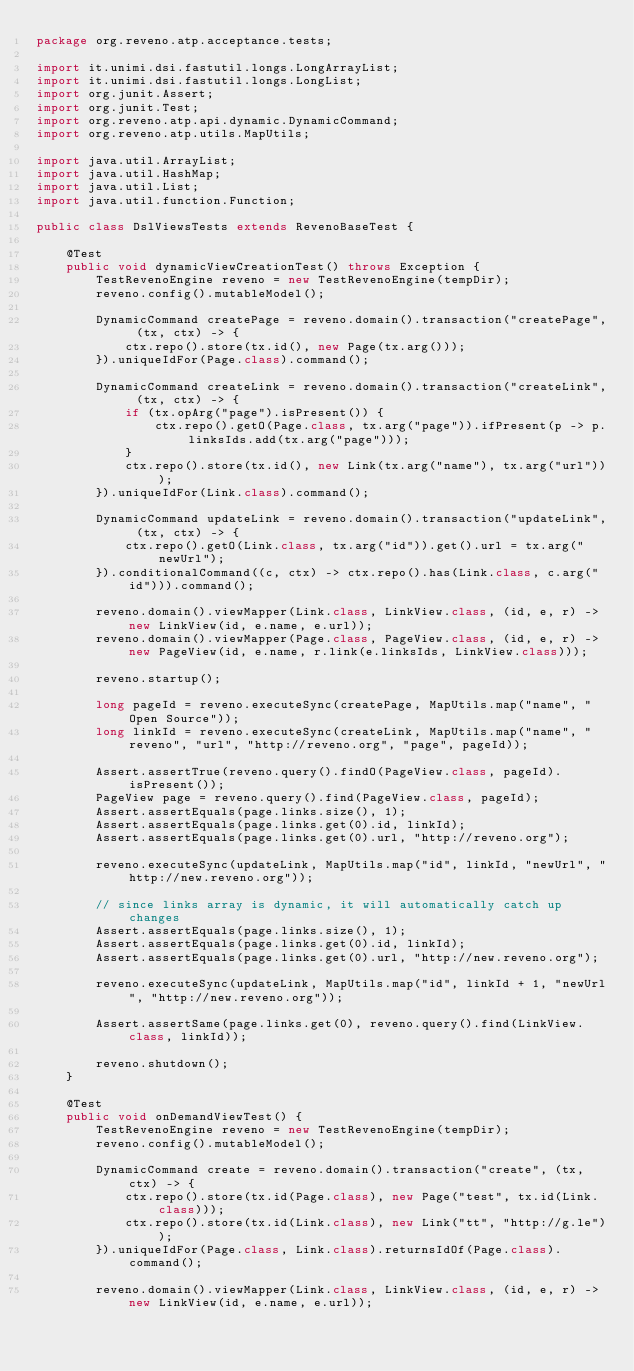Convert code to text. <code><loc_0><loc_0><loc_500><loc_500><_Java_>package org.reveno.atp.acceptance.tests;

import it.unimi.dsi.fastutil.longs.LongArrayList;
import it.unimi.dsi.fastutil.longs.LongList;
import org.junit.Assert;
import org.junit.Test;
import org.reveno.atp.api.dynamic.DynamicCommand;
import org.reveno.atp.utils.MapUtils;

import java.util.ArrayList;
import java.util.HashMap;
import java.util.List;
import java.util.function.Function;

public class DslViewsTests extends RevenoBaseTest {

    @Test
    public void dynamicViewCreationTest() throws Exception {
        TestRevenoEngine reveno = new TestRevenoEngine(tempDir);
        reveno.config().mutableModel();

        DynamicCommand createPage = reveno.domain().transaction("createPage", (tx, ctx) -> {
            ctx.repo().store(tx.id(), new Page(tx.arg()));
        }).uniqueIdFor(Page.class).command();

        DynamicCommand createLink = reveno.domain().transaction("createLink", (tx, ctx) -> {
            if (tx.opArg("page").isPresent()) {
                ctx.repo().getO(Page.class, tx.arg("page")).ifPresent(p -> p.linksIds.add(tx.arg("page")));
            }
            ctx.repo().store(tx.id(), new Link(tx.arg("name"), tx.arg("url")));
        }).uniqueIdFor(Link.class).command();

        DynamicCommand updateLink = reveno.domain().transaction("updateLink", (tx, ctx) -> {
            ctx.repo().getO(Link.class, tx.arg("id")).get().url = tx.arg("newUrl");
        }).conditionalCommand((c, ctx) -> ctx.repo().has(Link.class, c.arg("id"))).command();

        reveno.domain().viewMapper(Link.class, LinkView.class, (id, e, r) -> new LinkView(id, e.name, e.url));
        reveno.domain().viewMapper(Page.class, PageView.class, (id, e, r) -> new PageView(id, e.name, r.link(e.linksIds, LinkView.class)));

        reveno.startup();

        long pageId = reveno.executeSync(createPage, MapUtils.map("name", "Open Source"));
        long linkId = reveno.executeSync(createLink, MapUtils.map("name", "reveno", "url", "http://reveno.org", "page", pageId));

        Assert.assertTrue(reveno.query().findO(PageView.class, pageId).isPresent());
        PageView page = reveno.query().find(PageView.class, pageId);
        Assert.assertEquals(page.links.size(), 1);
        Assert.assertEquals(page.links.get(0).id, linkId);
        Assert.assertEquals(page.links.get(0).url, "http://reveno.org");

        reveno.executeSync(updateLink, MapUtils.map("id", linkId, "newUrl", "http://new.reveno.org"));

        // since links array is dynamic, it will automatically catch up changes
        Assert.assertEquals(page.links.size(), 1);
        Assert.assertEquals(page.links.get(0).id, linkId);
        Assert.assertEquals(page.links.get(0).url, "http://new.reveno.org");

        reveno.executeSync(updateLink, MapUtils.map("id", linkId + 1, "newUrl", "http://new.reveno.org"));

        Assert.assertSame(page.links.get(0), reveno.query().find(LinkView.class, linkId));

        reveno.shutdown();
    }

    @Test
    public void onDemandViewTest() {
        TestRevenoEngine reveno = new TestRevenoEngine(tempDir);
        reveno.config().mutableModel();

        DynamicCommand create = reveno.domain().transaction("create", (tx, ctx) -> {
            ctx.repo().store(tx.id(Page.class), new Page("test", tx.id(Link.class)));
            ctx.repo().store(tx.id(Link.class), new Link("tt", "http://g.le"));
        }).uniqueIdFor(Page.class, Link.class).returnsIdOf(Page.class).command();

        reveno.domain().viewMapper(Link.class, LinkView.class, (id, e, r) -> new LinkView(id, e.name, e.url));</code> 